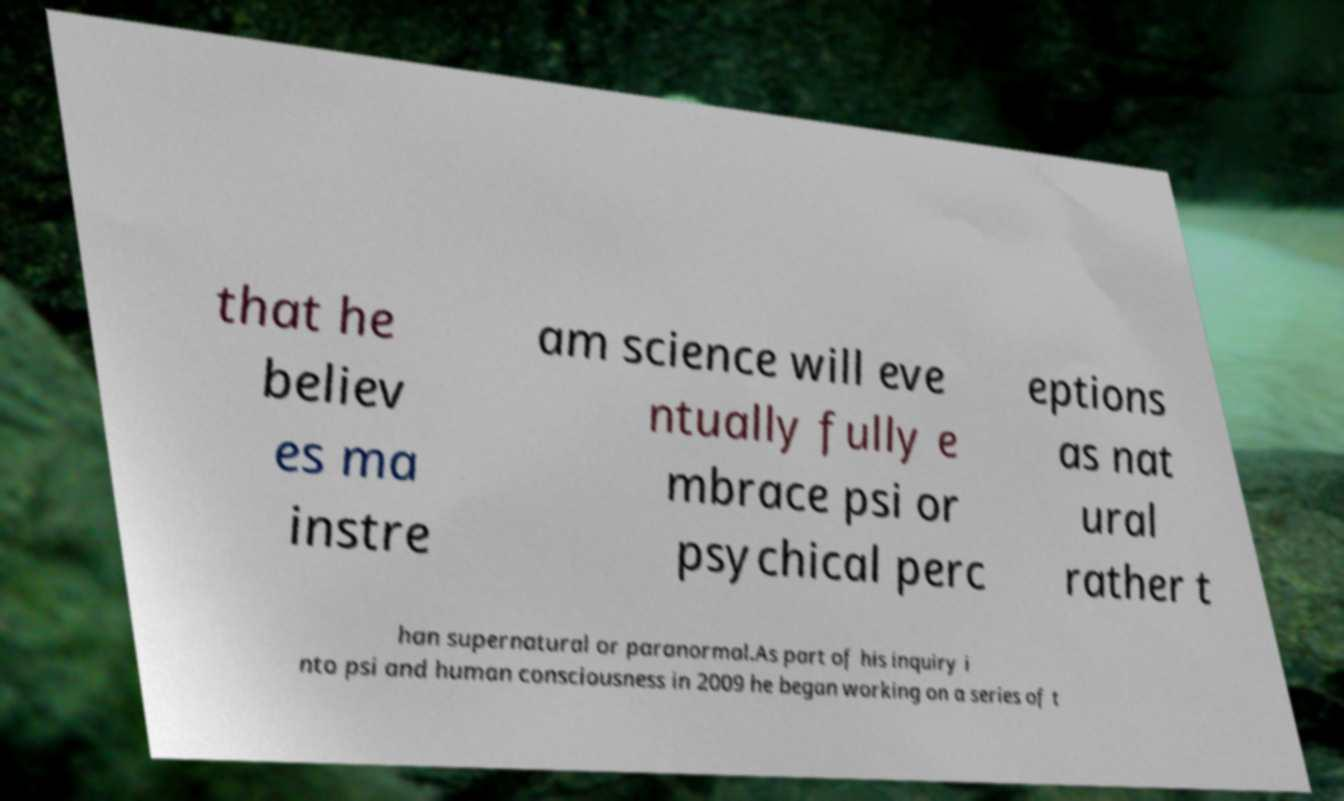I need the written content from this picture converted into text. Can you do that? that he believ es ma instre am science will eve ntually fully e mbrace psi or psychical perc eptions as nat ural rather t han supernatural or paranormal.As part of his inquiry i nto psi and human consciousness in 2009 he began working on a series of t 